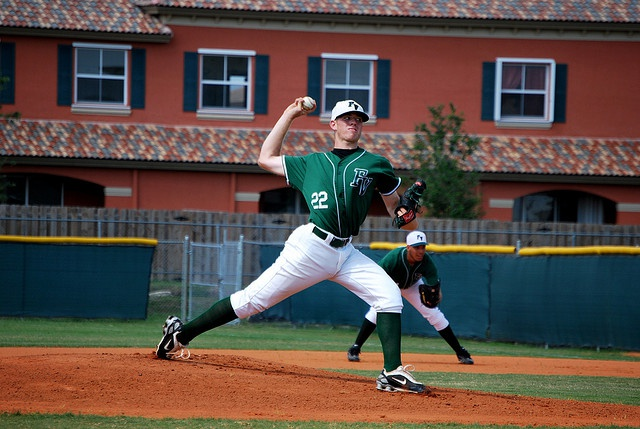Describe the objects in this image and their specific colors. I can see people in gray, black, white, teal, and darkgray tones, people in gray, black, teal, lavender, and maroon tones, baseball glove in gray, black, teal, and maroon tones, baseball glove in gray, black, darkblue, and maroon tones, and sports ball in gray, lightgray, darkgray, and maroon tones in this image. 